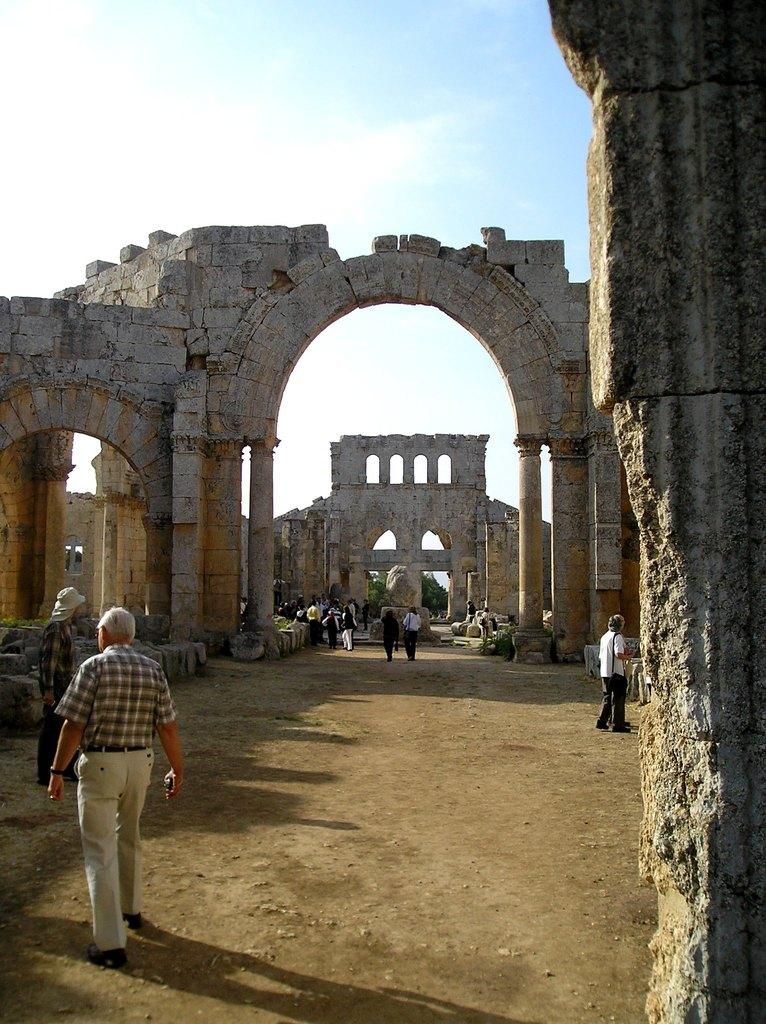How many people are in the image? There are few persons in the image. What architectural feature can be seen in the image? There is an arch in the image. What other structural elements are present in the image? There are pillars in the image. What type of background is visible in the image? The sky is visible in the background of the image. What is the main architectural structure in the image? The wall is the main architectural structure in the image. What is the point of balance for the detail on the arch in the image? There is no specific detail mentioned on the arch, and therefore no point of balance can be determined. 